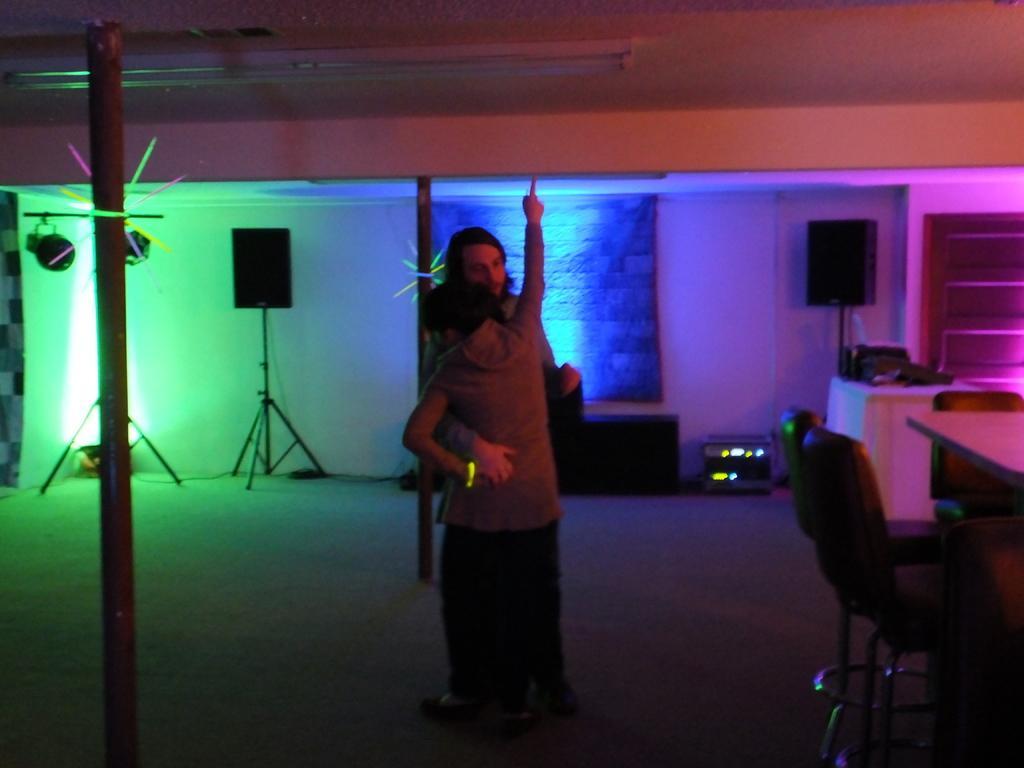Please provide a concise description of this image. In this image there are two persons standing on the floor by hugging each other. In the background there are speakers. At the top there is a tube light. On the left side there is a pole. Behind the pole there are lights. On the right side there is a table. Beside the table there are chairs. In the background there is a curtain. Beside the curtain there is a small device. 